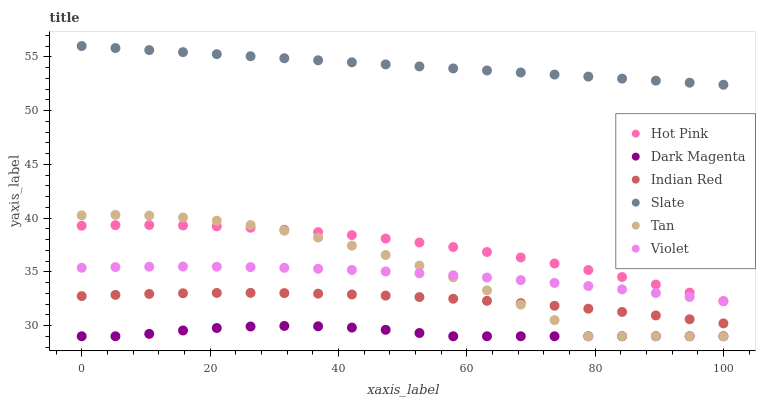Does Dark Magenta have the minimum area under the curve?
Answer yes or no. Yes. Does Slate have the maximum area under the curve?
Answer yes or no. Yes. Does Hot Pink have the minimum area under the curve?
Answer yes or no. No. Does Hot Pink have the maximum area under the curve?
Answer yes or no. No. Is Slate the smoothest?
Answer yes or no. Yes. Is Tan the roughest?
Answer yes or no. Yes. Is Hot Pink the smoothest?
Answer yes or no. No. Is Hot Pink the roughest?
Answer yes or no. No. Does Dark Magenta have the lowest value?
Answer yes or no. Yes. Does Hot Pink have the lowest value?
Answer yes or no. No. Does Slate have the highest value?
Answer yes or no. Yes. Does Hot Pink have the highest value?
Answer yes or no. No. Is Dark Magenta less than Hot Pink?
Answer yes or no. Yes. Is Hot Pink greater than Dark Magenta?
Answer yes or no. Yes. Does Violet intersect Tan?
Answer yes or no. Yes. Is Violet less than Tan?
Answer yes or no. No. Is Violet greater than Tan?
Answer yes or no. No. Does Dark Magenta intersect Hot Pink?
Answer yes or no. No. 